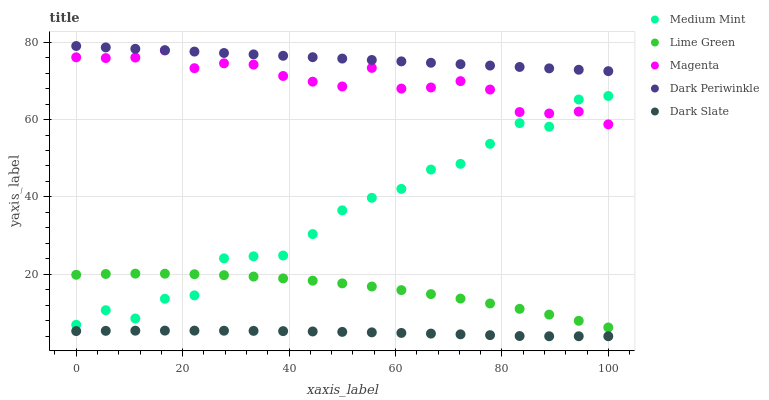Does Dark Slate have the minimum area under the curve?
Answer yes or no. Yes. Does Dark Periwinkle have the maximum area under the curve?
Answer yes or no. Yes. Does Magenta have the minimum area under the curve?
Answer yes or no. No. Does Magenta have the maximum area under the curve?
Answer yes or no. No. Is Dark Periwinkle the smoothest?
Answer yes or no. Yes. Is Medium Mint the roughest?
Answer yes or no. Yes. Is Dark Slate the smoothest?
Answer yes or no. No. Is Dark Slate the roughest?
Answer yes or no. No. Does Dark Slate have the lowest value?
Answer yes or no. Yes. Does Magenta have the lowest value?
Answer yes or no. No. Does Dark Periwinkle have the highest value?
Answer yes or no. Yes. Does Magenta have the highest value?
Answer yes or no. No. Is Lime Green less than Dark Periwinkle?
Answer yes or no. Yes. Is Lime Green greater than Dark Slate?
Answer yes or no. Yes. Does Lime Green intersect Medium Mint?
Answer yes or no. Yes. Is Lime Green less than Medium Mint?
Answer yes or no. No. Is Lime Green greater than Medium Mint?
Answer yes or no. No. Does Lime Green intersect Dark Periwinkle?
Answer yes or no. No. 